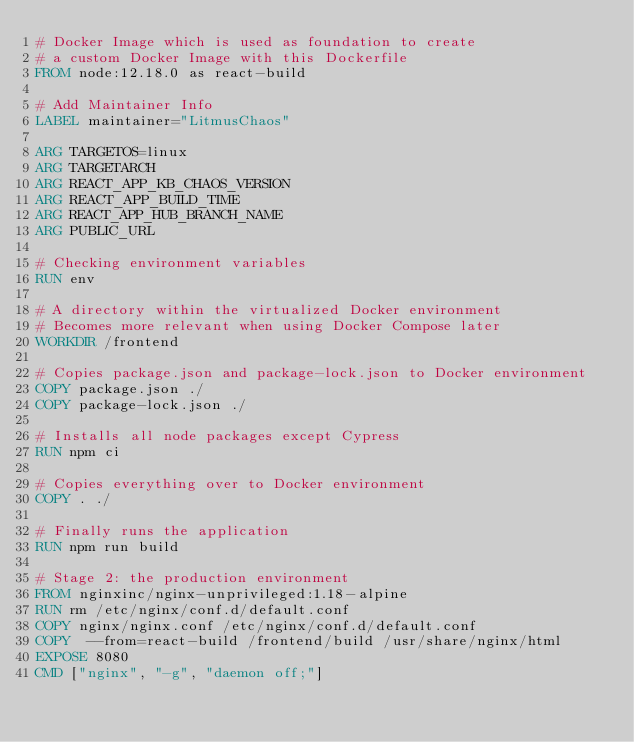Convert code to text. <code><loc_0><loc_0><loc_500><loc_500><_Dockerfile_># Docker Image which is used as foundation to create
# a custom Docker Image with this Dockerfile
FROM node:12.18.0 as react-build

# Add Maintainer Info
LABEL maintainer="LitmusChaos"

ARG TARGETOS=linux
ARG TARGETARCH
ARG REACT_APP_KB_CHAOS_VERSION
ARG REACT_APP_BUILD_TIME
ARG REACT_APP_HUB_BRANCH_NAME
ARG PUBLIC_URL

# Checking environment variables
RUN env

# A directory within the virtualized Docker environment
# Becomes more relevant when using Docker Compose later
WORKDIR /frontend

# Copies package.json and package-lock.json to Docker environment
COPY package.json ./
COPY package-lock.json ./

# Installs all node packages except Cypress
RUN npm ci

# Copies everything over to Docker environment
COPY . ./

# Finally runs the application
RUN npm run build

# Stage 2: the production environment
FROM nginxinc/nginx-unprivileged:1.18-alpine
RUN rm /etc/nginx/conf.d/default.conf
COPY nginx/nginx.conf /etc/nginx/conf.d/default.conf
COPY  --from=react-build /frontend/build /usr/share/nginx/html
EXPOSE 8080
CMD ["nginx", "-g", "daemon off;"]
</code> 